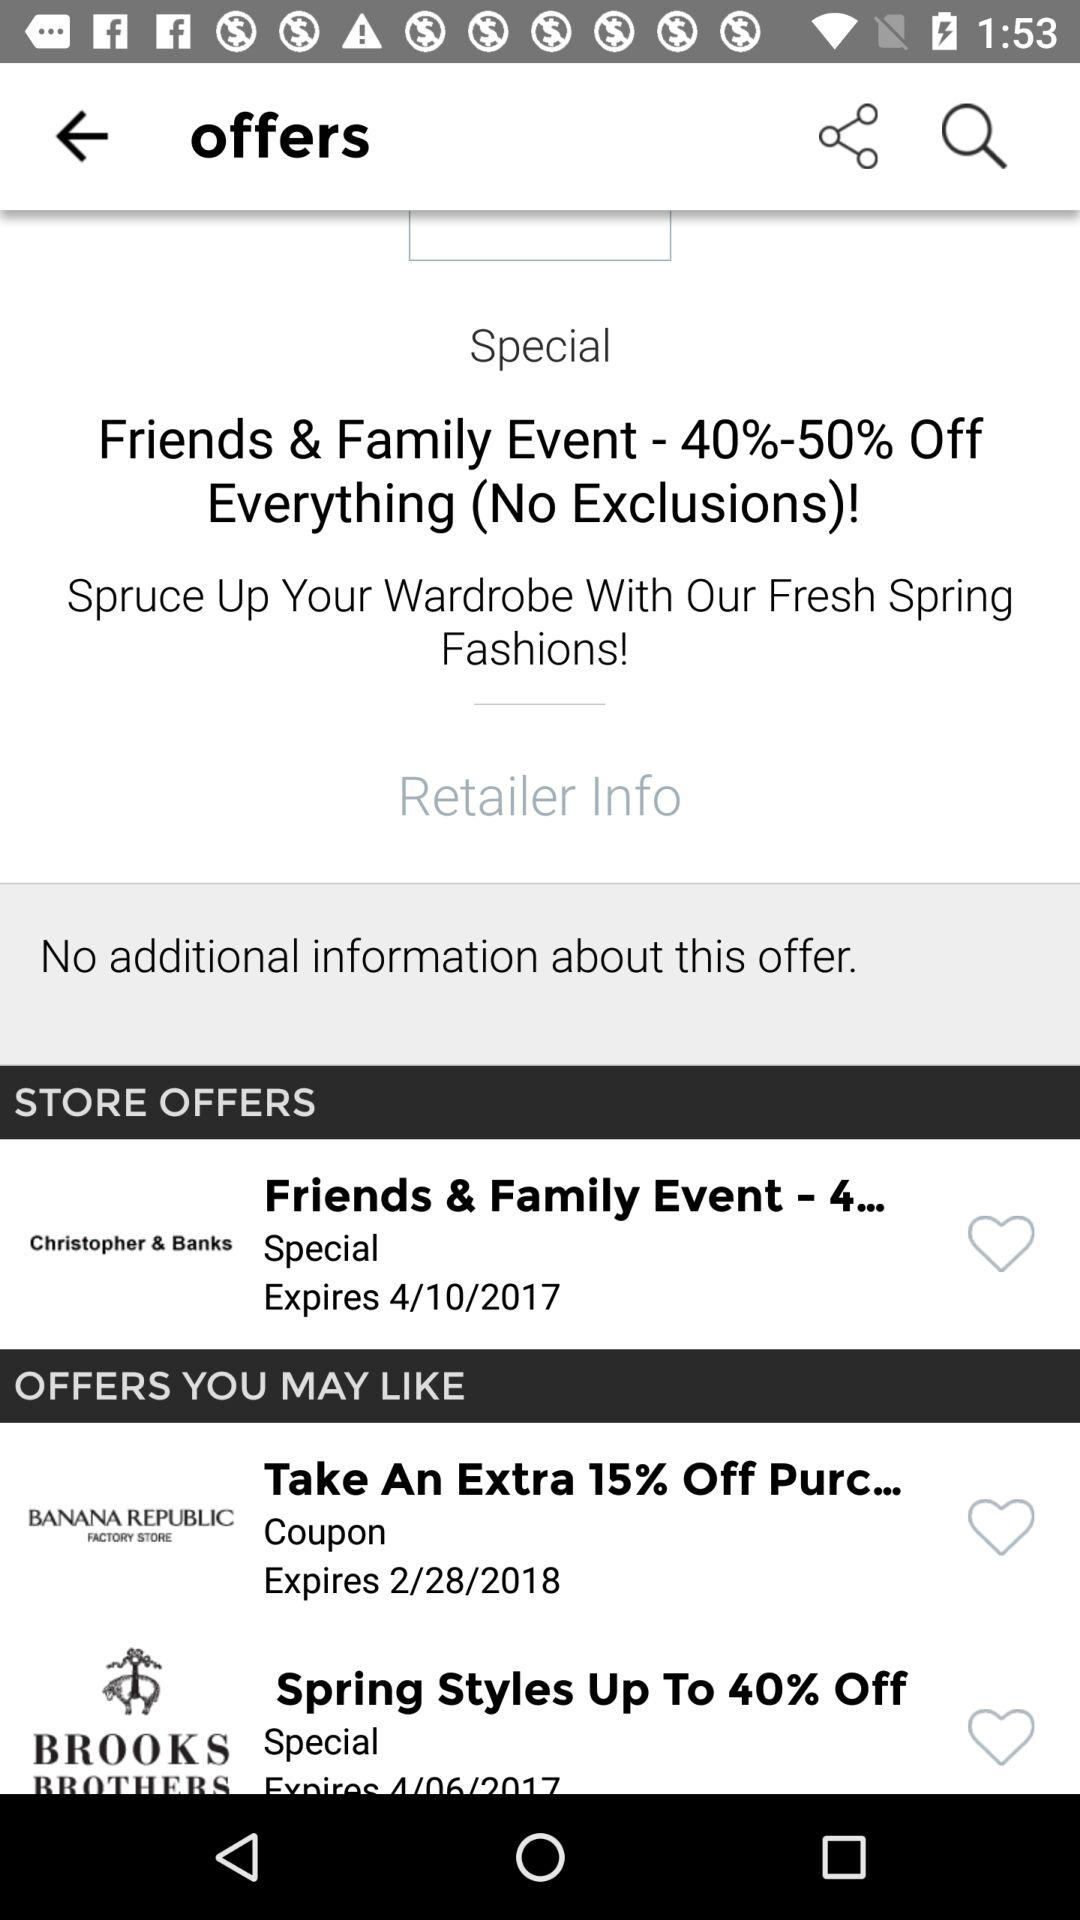How many store offers are there?
Answer the question using a single word or phrase. 3 